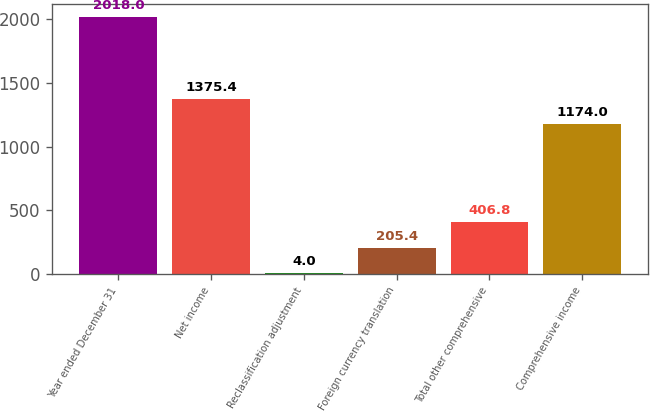<chart> <loc_0><loc_0><loc_500><loc_500><bar_chart><fcel>Year ended December 31<fcel>Net income<fcel>Reclassification adjustment<fcel>Foreign currency translation<fcel>Total other comprehensive<fcel>Comprehensive income<nl><fcel>2018<fcel>1375.4<fcel>4<fcel>205.4<fcel>406.8<fcel>1174<nl></chart> 